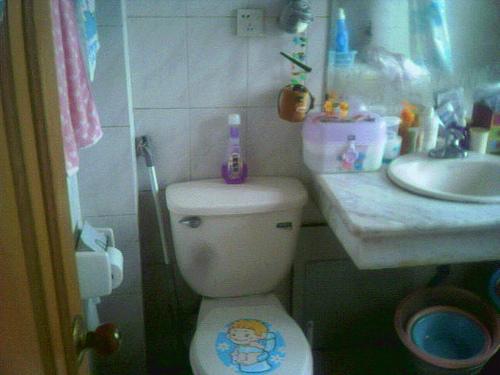Does this restroom usually get used by a child?
Concise answer only. Yes. Do you see a waste basket?
Keep it brief. Yes. On what side of the picture is the toilet?
Write a very short answer. Left. Is there toilet paper?
Quick response, please. Yes. 